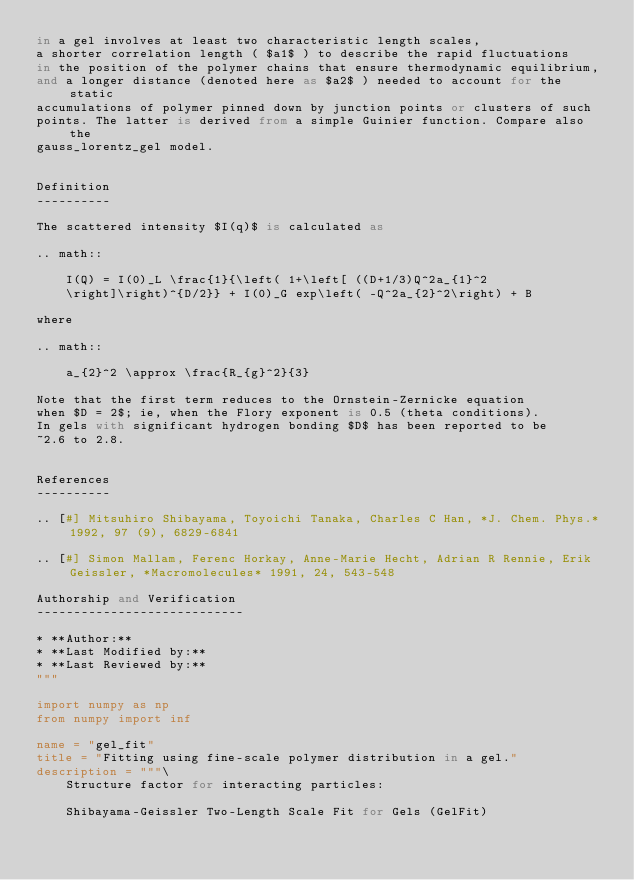Convert code to text. <code><loc_0><loc_0><loc_500><loc_500><_Python_>in a gel involves at least two characteristic length scales,
a shorter correlation length ( $a1$ ) to describe the rapid fluctuations
in the position of the polymer chains that ensure thermodynamic equilibrium,
and a longer distance (denoted here as $a2$ ) needed to account for the static
accumulations of polymer pinned down by junction points or clusters of such
points. The latter is derived from a simple Guinier function. Compare also the
gauss_lorentz_gel model.


Definition
----------

The scattered intensity $I(q)$ is calculated as

.. math::

    I(Q) = I(0)_L \frac{1}{\left( 1+\left[ ((D+1/3)Q^2a_{1}^2
    \right]\right)^{D/2}} + I(0)_G exp\left( -Q^2a_{2}^2\right) + B

where

.. math::

    a_{2}^2 \approx \frac{R_{g}^2}{3}

Note that the first term reduces to the Ornstein-Zernicke equation
when $D = 2$; ie, when the Flory exponent is 0.5 (theta conditions).
In gels with significant hydrogen bonding $D$ has been reported to be
~2.6 to 2.8.


References
----------

.. [#] Mitsuhiro Shibayama, Toyoichi Tanaka, Charles C Han, *J. Chem. Phys.* 1992, 97 (9), 6829-6841

.. [#] Simon Mallam, Ferenc Horkay, Anne-Marie Hecht, Adrian R Rennie, Erik Geissler, *Macromolecules* 1991, 24, 543-548

Authorship and Verification
----------------------------

* **Author:**
* **Last Modified by:**
* **Last Reviewed by:**
"""

import numpy as np
from numpy import inf

name = "gel_fit"
title = "Fitting using fine-scale polymer distribution in a gel."
description = """\
    Structure factor for interacting particles:

    Shibayama-Geissler Two-Length Scale Fit for Gels (GelFit)
</code> 